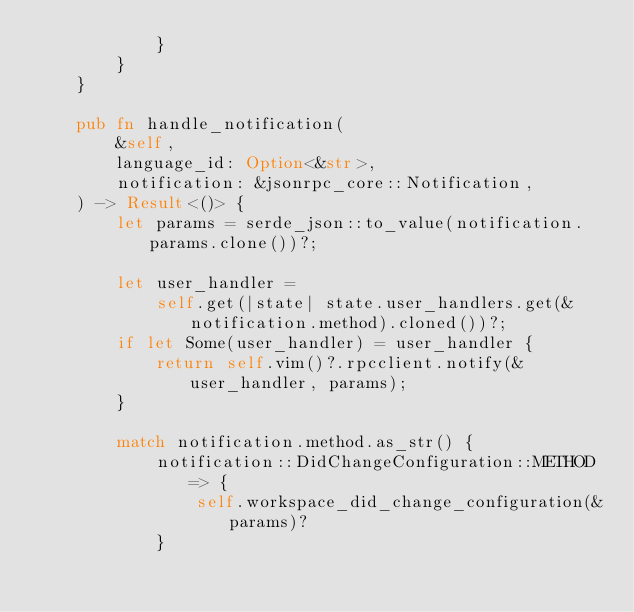<code> <loc_0><loc_0><loc_500><loc_500><_Rust_>            }
        }
    }

    pub fn handle_notification(
        &self,
        language_id: Option<&str>,
        notification: &jsonrpc_core::Notification,
    ) -> Result<()> {
        let params = serde_json::to_value(notification.params.clone())?;

        let user_handler =
            self.get(|state| state.user_handlers.get(&notification.method).cloned())?;
        if let Some(user_handler) = user_handler {
            return self.vim()?.rpcclient.notify(&user_handler, params);
        }

        match notification.method.as_str() {
            notification::DidChangeConfiguration::METHOD => {
                self.workspace_did_change_configuration(&params)?
            }</code> 